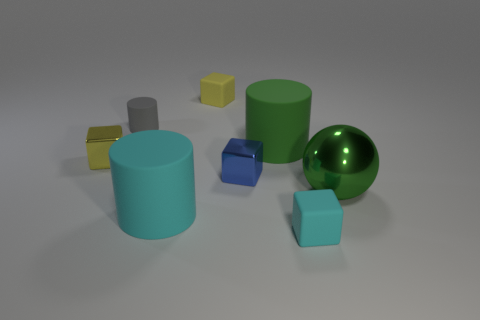What could be an imagined purpose for this collection of objects? While the objects may look random, one could imagine this as a simplified educational setup promoting the learning of 3D shapes and geometry. The different sizes, colors, and shapes could help teach sorting, spatial awareness, and color recognition. How might these objects be used in a mathematical context? In mathematics, these objects could be employed to teach concepts such as volume, surface area, and the properties of different geometric figures. Students could compare and contrast the dimensions of the cylinders, the cube, and the sphere to gain hands-on experience with these concepts. 